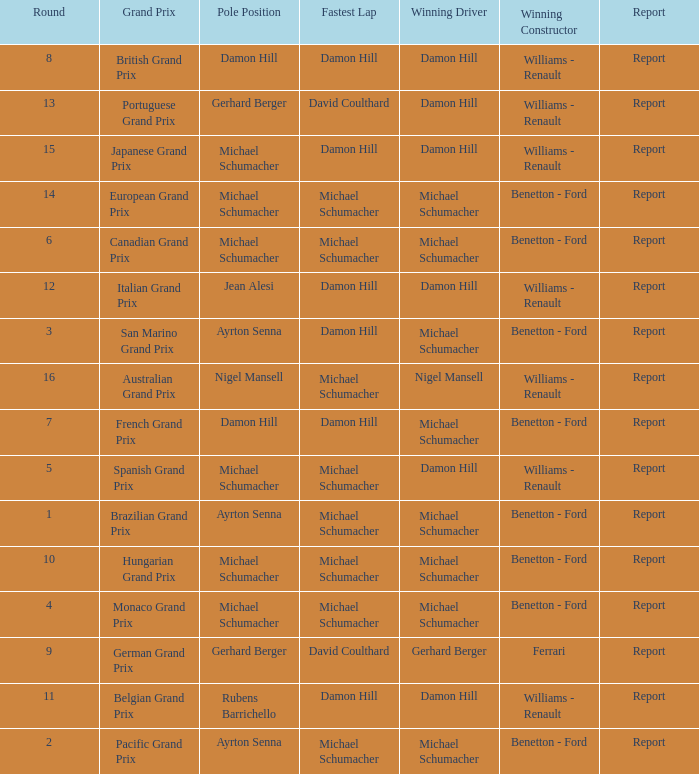Name the pole position at the japanese grand prix when the fastest lap is damon hill Michael Schumacher. 